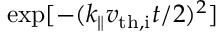<formula> <loc_0><loc_0><loc_500><loc_500>\exp [ - ( k _ { \| } v _ { t h , i } t / 2 ) ^ { 2 } ]</formula> 